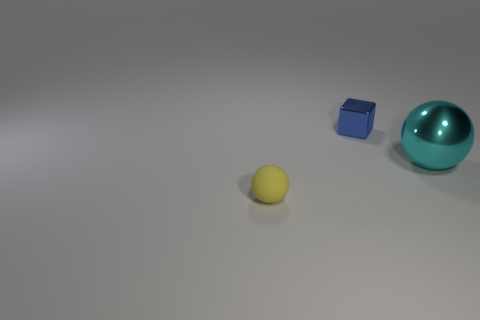How many cyan objects are either tiny rubber cylinders or metallic spheres?
Ensure brevity in your answer.  1. Are there fewer tiny metal cubes that are in front of the small blue block than balls that are behind the small yellow matte thing?
Your answer should be compact. Yes. Are there any other matte things of the same size as the blue thing?
Provide a short and direct response. Yes. Does the thing behind the cyan ball have the same size as the tiny matte ball?
Make the answer very short. Yes. Is the number of large cyan metal objects greater than the number of cyan metallic cylinders?
Your answer should be compact. Yes. Are there any tiny yellow things of the same shape as the big object?
Provide a succinct answer. Yes. What is the shape of the object that is to the left of the metal cube?
Provide a short and direct response. Sphere. There is a ball that is on the left side of the shiny thing to the left of the large cyan metallic sphere; how many small cubes are right of it?
Offer a terse response. 1. How many other objects are the same shape as the tiny matte thing?
Ensure brevity in your answer.  1. How many other things are there of the same material as the small yellow ball?
Keep it short and to the point. 0. 